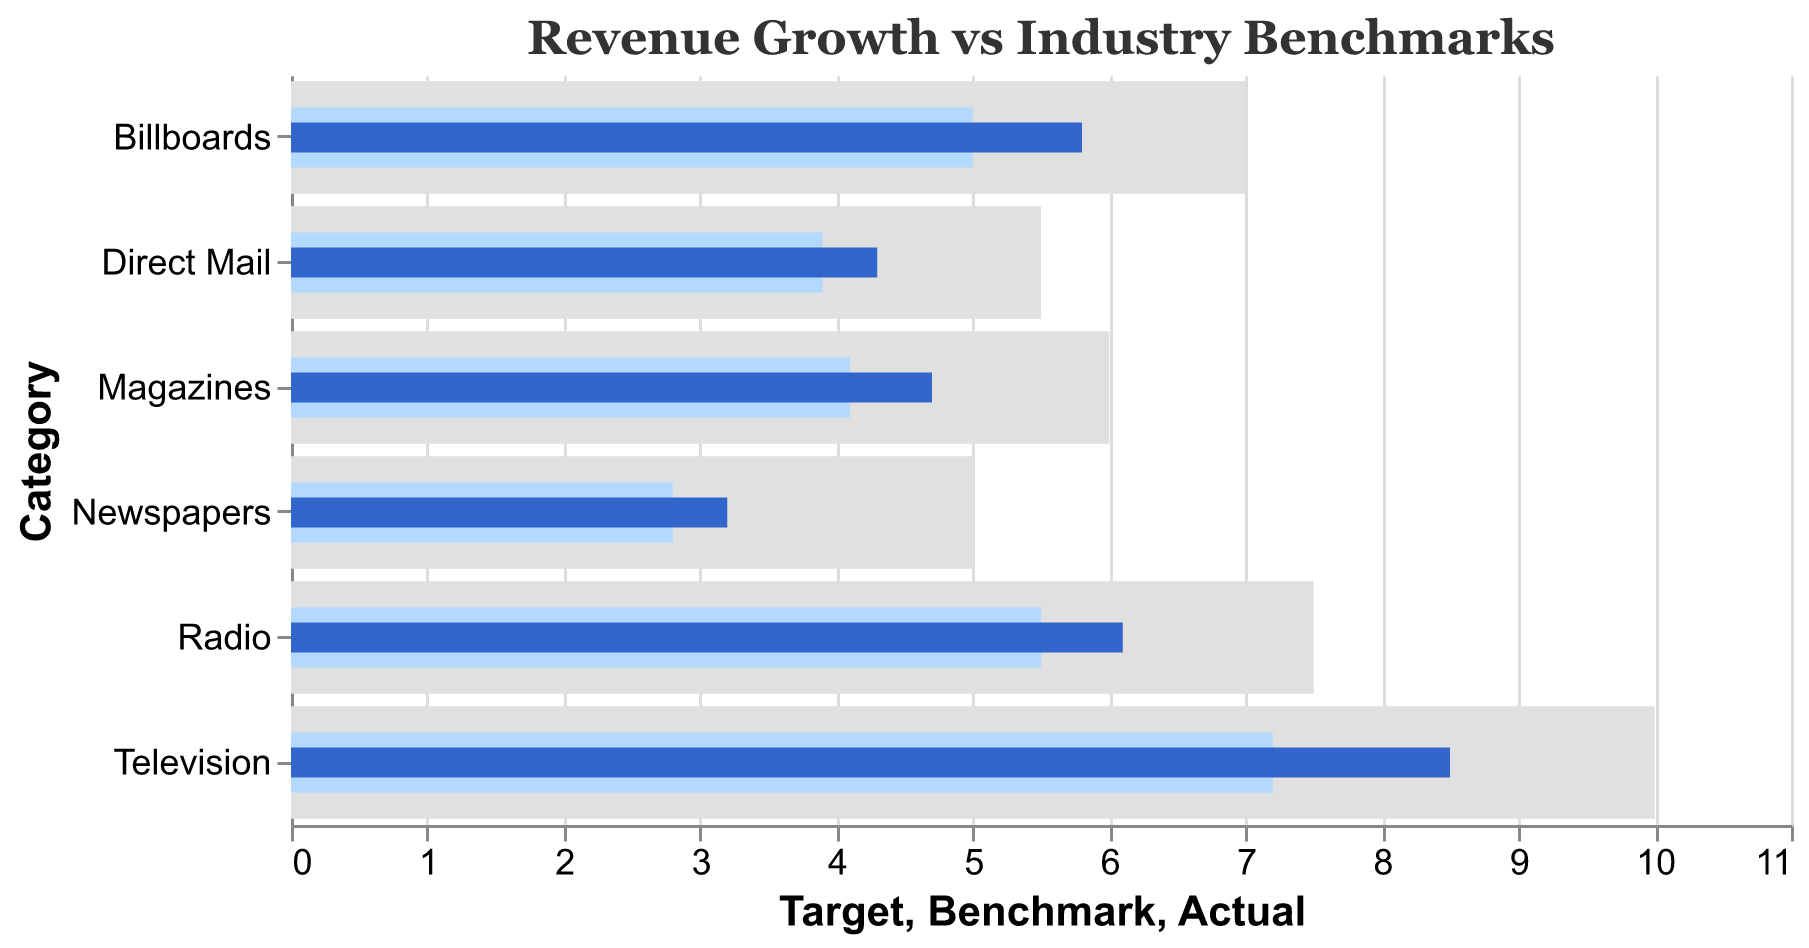What's the title of the chart? The title of the chart is written at the top and it states the main focus of the visualized data. The title is "Revenue Growth vs Industry Benchmarks"
Answer: Revenue Growth vs Industry Benchmarks How many advertising channels are displayed in the chart? By counting the number of distinct categories along the y-axis, we can determine the number of advertising channels displayed. Each category represents a different traditional advertising channel.
Answer: 6 What is the actual revenue growth for Radio? By locating the category "Radio" on the y-axis and checking the actual revenue growth bar's position along the x-axis, we find the value.
Answer: 6.1 Which advertising channel has the highest actual revenue growth? We compare the lengths of the blue bars representing actual revenue growth for each category. The longest bar indicates the highest actual revenue growth. The "Television" category has the longest bar.
Answer: Television How much higher is the actual revenue growth for Television compared to the Benchmark in the same category? For the "Television" category, subtract the benchmark value from the actual revenue growth value. Actual (8.5) - Benchmark (7.2) = 1.3.
Answer: 1.3 Which advertising channel is closest to its target growth? We look for the smallest difference between the actual revenue growth bar and the target bar for each category. The category with the smallest gap is "Television".
Answer: Television What is the difference between the actual and target revenue growth for Direct Mail? For the "Direct Mail" category, subtract the actual revenue growth value from the target value. Target (5.5) - Actual (4.3) = 1.2.
Answer: 1.2 Among Magazines and Newspapers, which one exceeds its benchmark by a larger margin? Compare the difference between the actual and benchmark values for both categories. Magazines: Actual (4.7) - Benchmark (4.1) = 0.6. Newspapers: Actual (3.2) - Benchmark (2.8) = 0.4. Magazines exceed their benchmark by a larger margin (0.6 vs 0.4).
Answer: Magazines What is the total benchmark value for all advertising channels combined? Sum the benchmark values for all categories: (7.2 + 2.8 + 4.1 + 5.5 + 5.0 + 3.9). Total = 28.5.
Answer: 28.5 